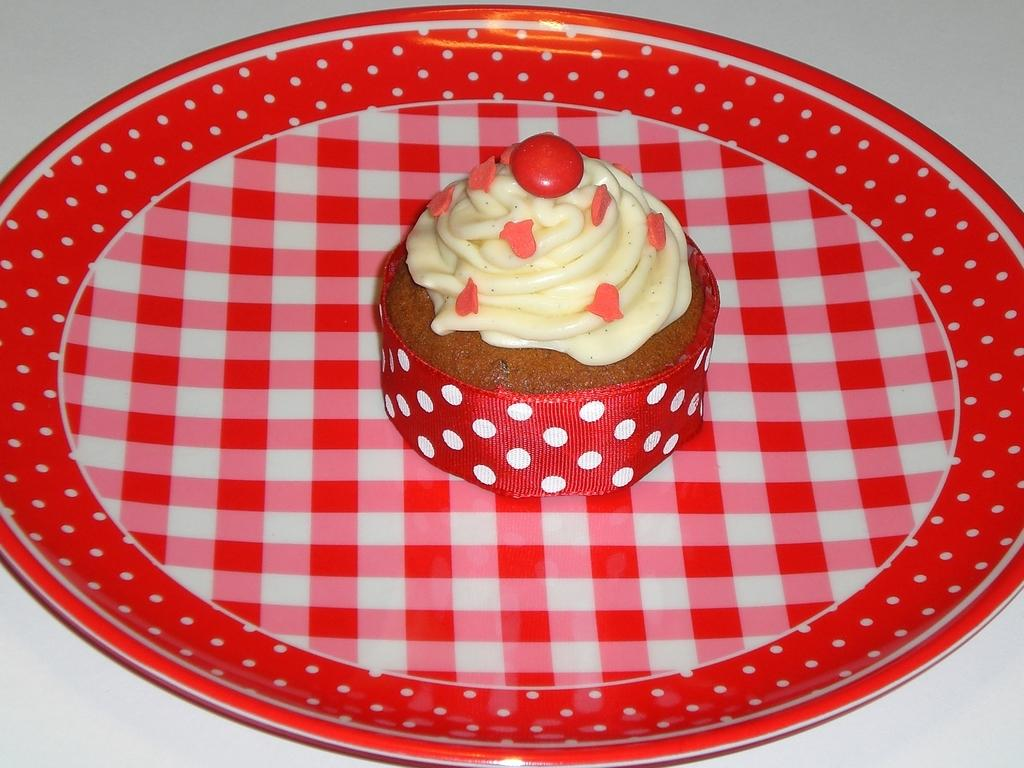What type of dessert is in the picture? There is a small cupcake in the picture. What decoration is on the cupcake? The cupcake has sprinklers. What color is the plate that the cupcake is on? The cupcake is placed on a red color plate. Is the red color plate visible in the image? Yes, the red color plate is present in the image. Where is the red color plate located? The red color plate is placed on a table. What type of cheese can be seen on the cupcake in the image? There is no cheese present on the cupcake in the image; it has sprinklers instead. 